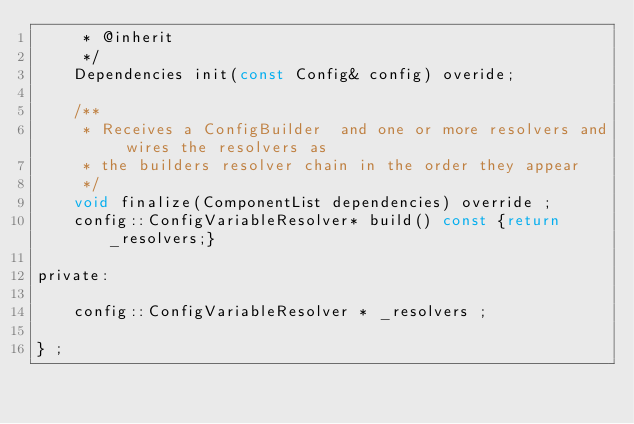<code> <loc_0><loc_0><loc_500><loc_500><_C_>     * @inherit
     */
	Dependencies init(const Config& config) overide;
   
    /**
     * Receives a ConfigBuilder  and one or more resolvers and wires the resolvers as 
     * the builders resolver chain in the order they appear
     */
    void finalize(ComponentList dependencies) override ;
    config::ConfigVariableResolver* build() const {return _resolvers;}

private:

    config::ConfigVariableResolver * _resolvers ;
    
} ;
</code> 